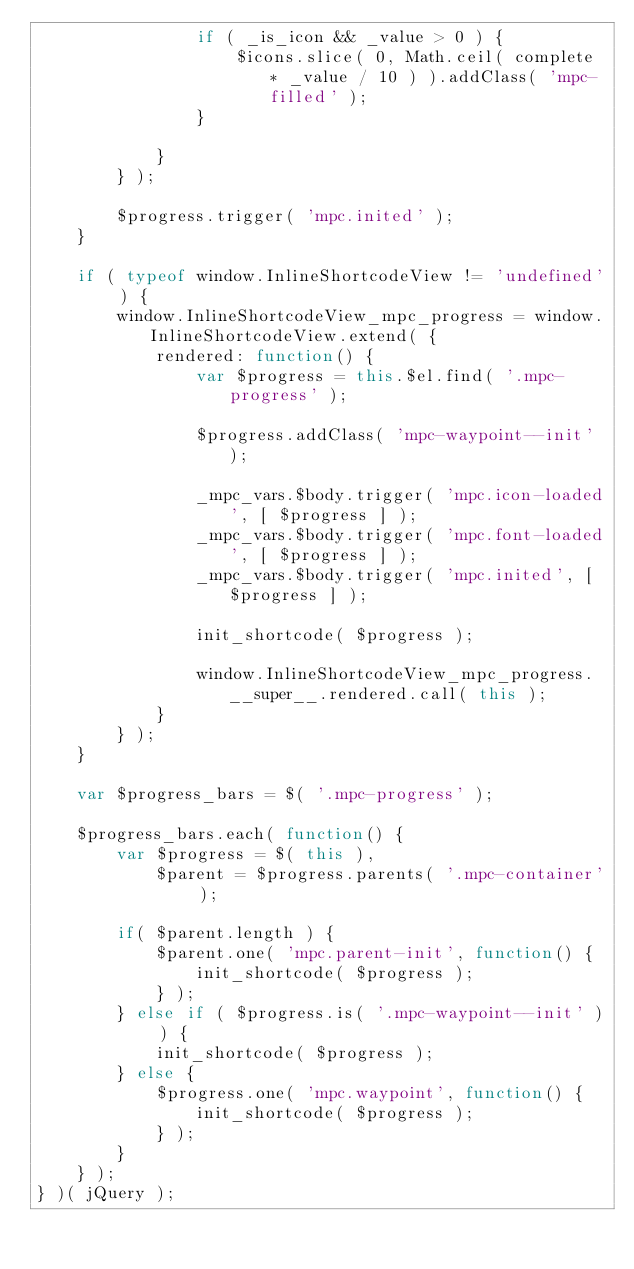Convert code to text. <code><loc_0><loc_0><loc_500><loc_500><_JavaScript_>				if ( _is_icon && _value > 0 ) {
					$icons.slice( 0, Math.ceil( complete * _value / 10 ) ).addClass( 'mpc-filled' );
				}

			}
		} );

		$progress.trigger( 'mpc.inited' );
	}

	if ( typeof window.InlineShortcodeView != 'undefined' ) {
		window.InlineShortcodeView_mpc_progress = window.InlineShortcodeView.extend( {
			rendered: function() {
				var $progress = this.$el.find( '.mpc-progress' );

				$progress.addClass( 'mpc-waypoint--init' );

				_mpc_vars.$body.trigger( 'mpc.icon-loaded', [ $progress ] );
				_mpc_vars.$body.trigger( 'mpc.font-loaded', [ $progress ] );
				_mpc_vars.$body.trigger( 'mpc.inited', [ $progress ] );

				init_shortcode( $progress );

				window.InlineShortcodeView_mpc_progress.__super__.rendered.call( this );
			}
		} );
	}

	var $progress_bars = $( '.mpc-progress' );

	$progress_bars.each( function() {
		var $progress = $( this ),
			$parent = $progress.parents( '.mpc-container' );

		if( $parent.length ) {
			$parent.one( 'mpc.parent-init', function() {
				init_shortcode( $progress );
			} );
		} else if ( $progress.is( '.mpc-waypoint--init' ) ) {
			init_shortcode( $progress );
		} else {
			$progress.one( 'mpc.waypoint', function() {
				init_shortcode( $progress );
			} );
		}
	} );
} )( jQuery );
</code> 